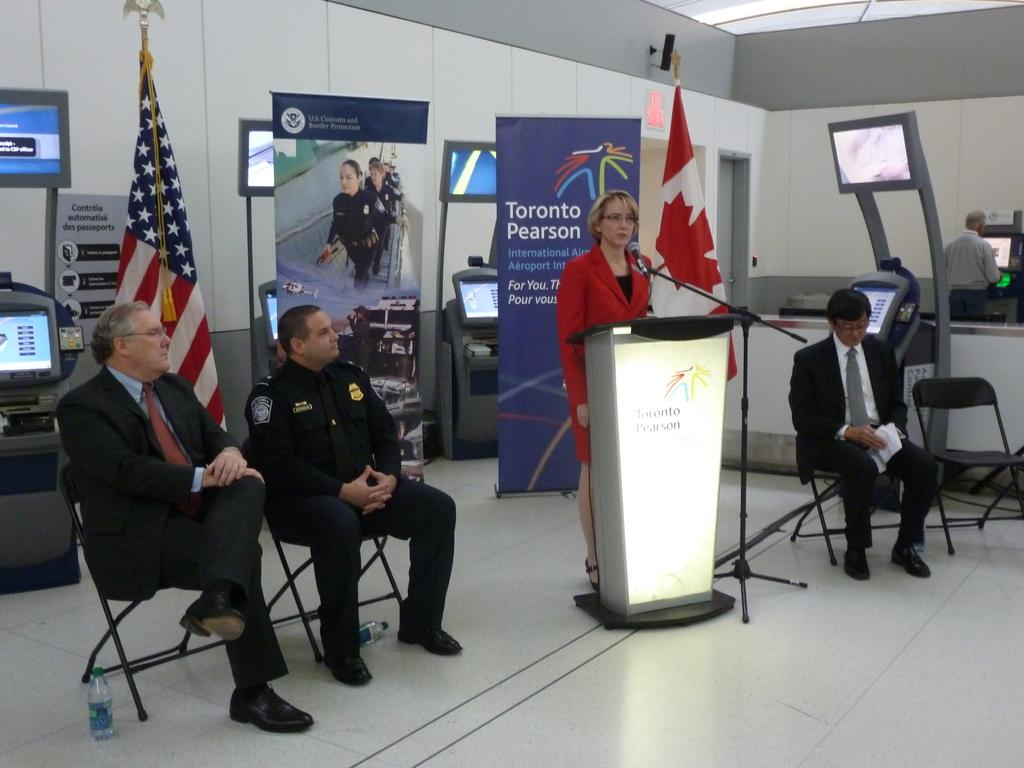<image>
Provide a brief description of the given image. Several people gather around for a discussion at Toronto Pearson. 